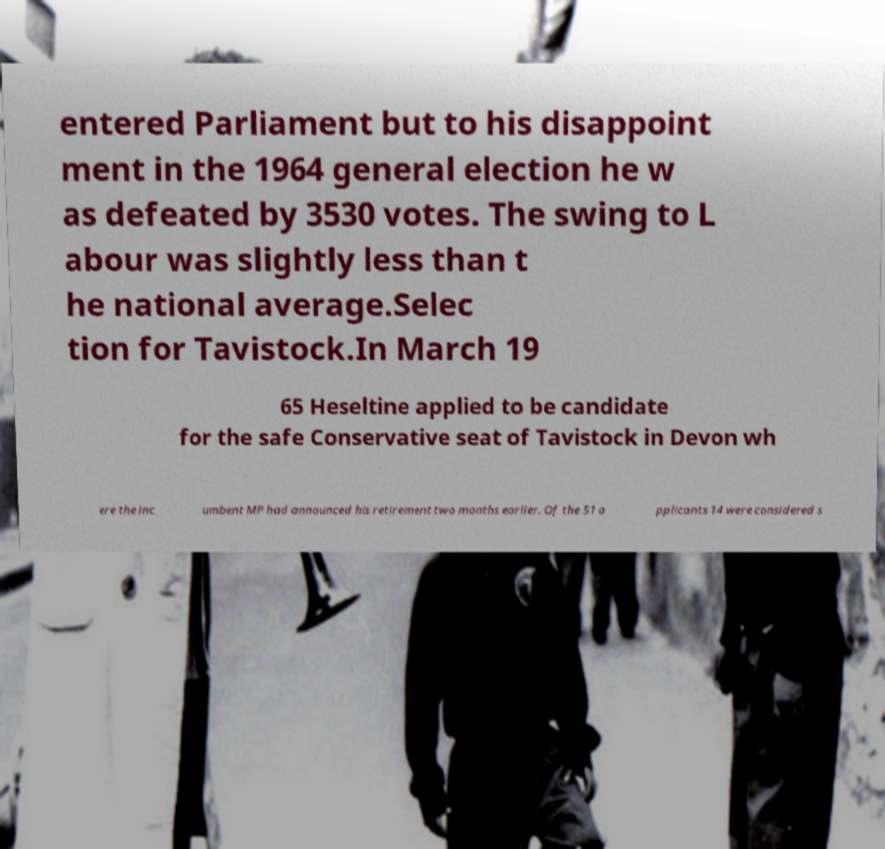Please identify and transcribe the text found in this image. entered Parliament but to his disappoint ment in the 1964 general election he w as defeated by 3530 votes. The swing to L abour was slightly less than t he national average.Selec tion for Tavistock.In March 19 65 Heseltine applied to be candidate for the safe Conservative seat of Tavistock in Devon wh ere the inc umbent MP had announced his retirement two months earlier. Of the 51 a pplicants 14 were considered s 